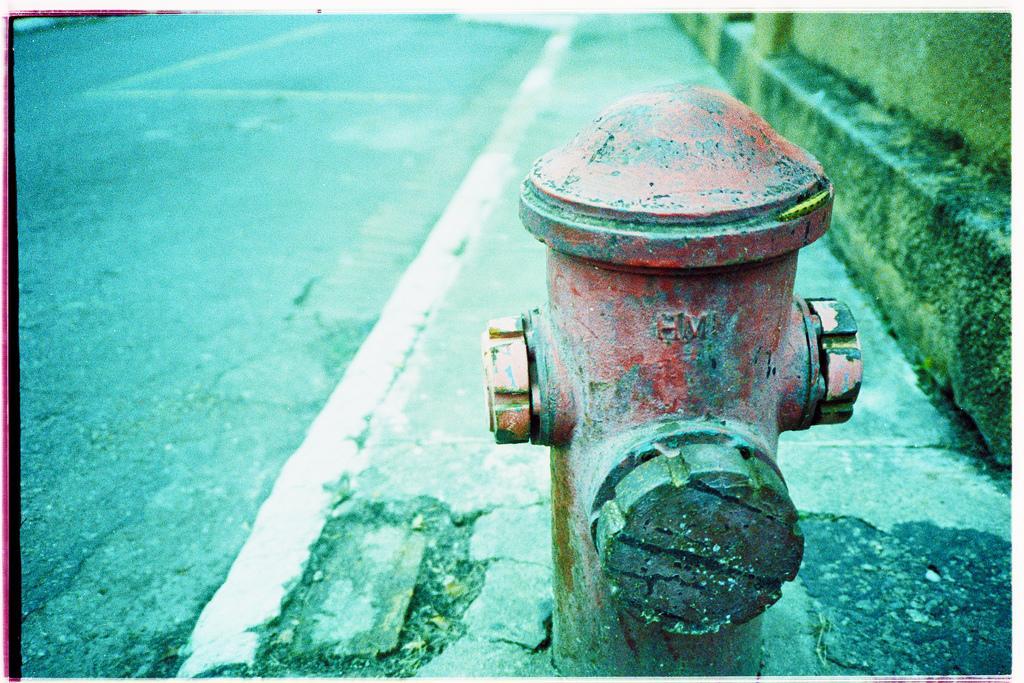Please provide a concise description of this image. In this picture there is a fire hydrant. On the right there is a wall. On the left i can see the road. 